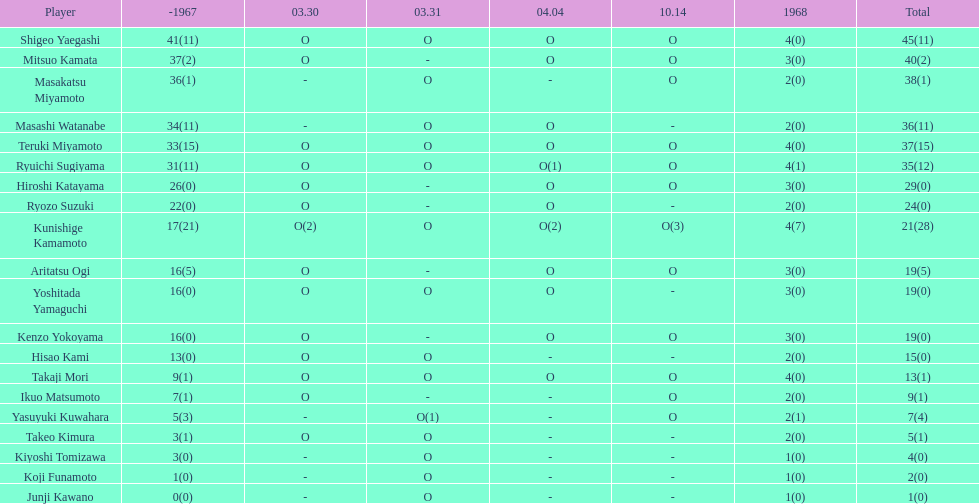How many players made an appearance that year? 20. 